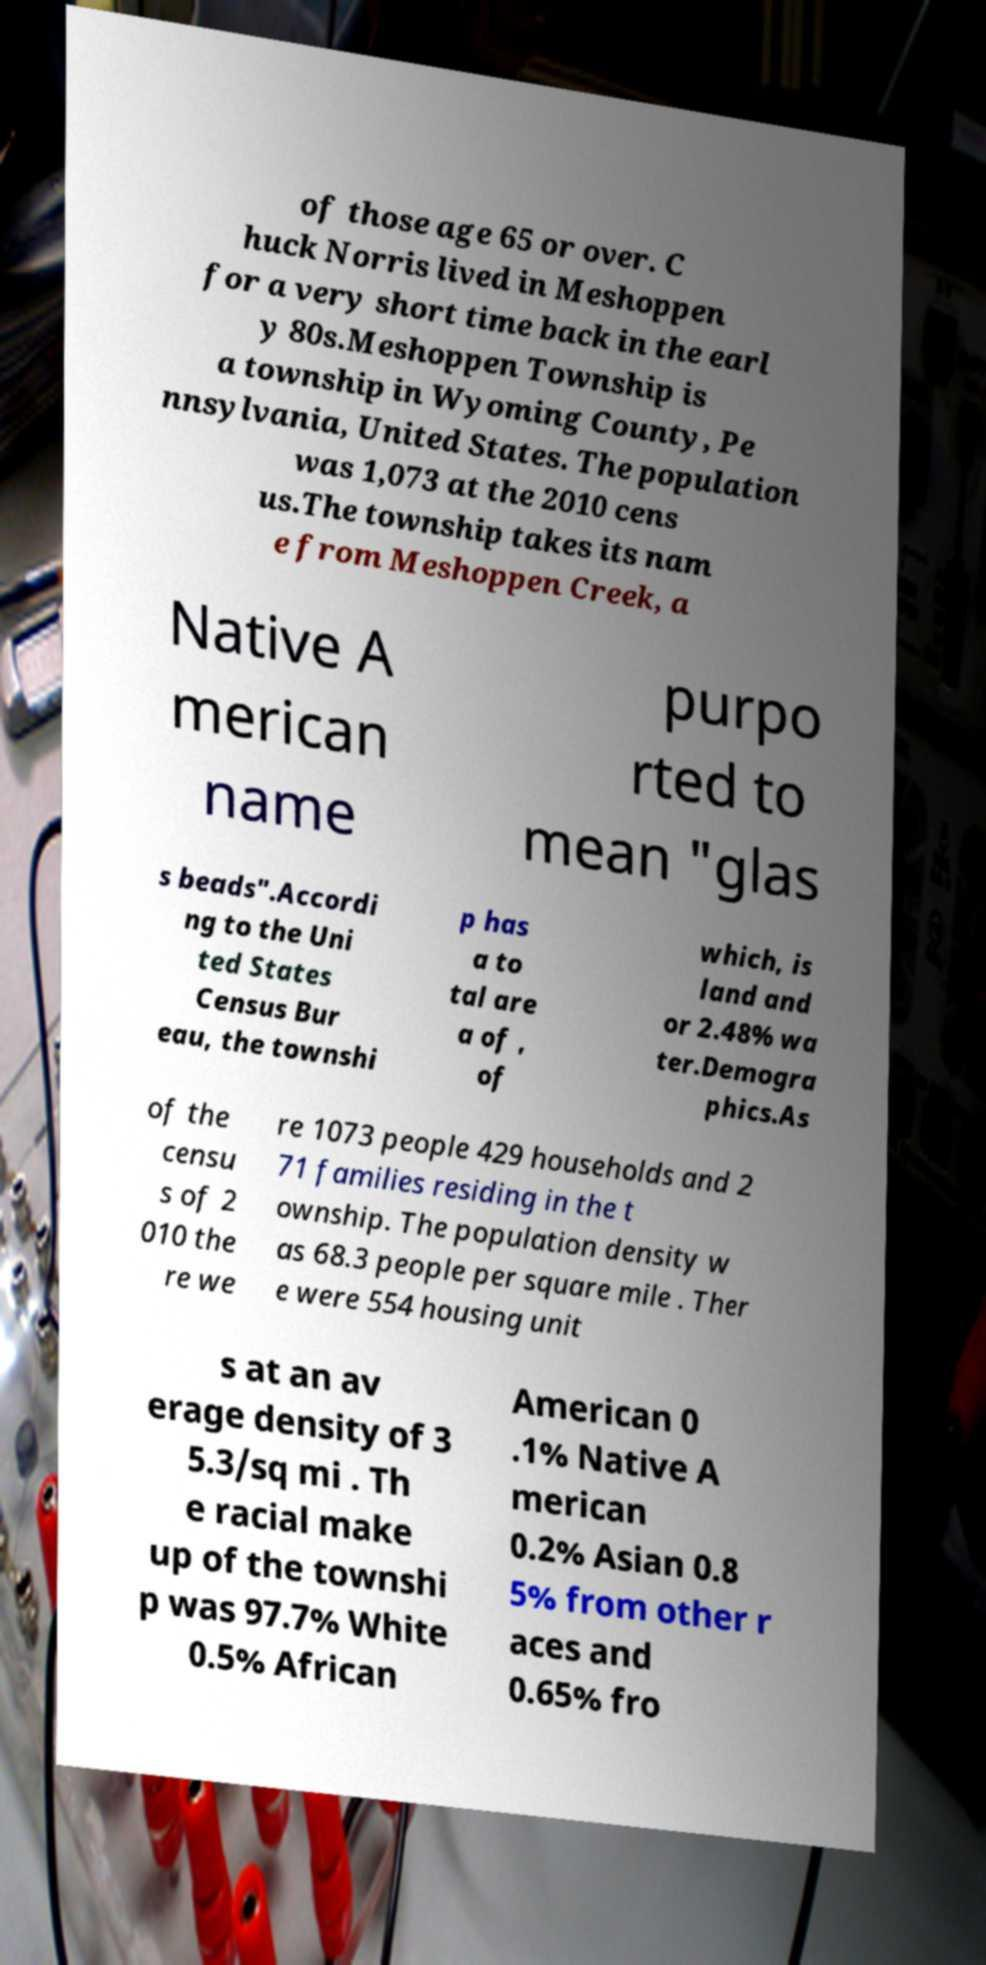Please identify and transcribe the text found in this image. of those age 65 or over. C huck Norris lived in Meshoppen for a very short time back in the earl y 80s.Meshoppen Township is a township in Wyoming County, Pe nnsylvania, United States. The population was 1,073 at the 2010 cens us.The township takes its nam e from Meshoppen Creek, a Native A merican name purpo rted to mean "glas s beads".Accordi ng to the Uni ted States Census Bur eau, the townshi p has a to tal are a of , of which, is land and or 2.48% wa ter.Demogra phics.As of the censu s of 2 010 the re we re 1073 people 429 households and 2 71 families residing in the t ownship. The population density w as 68.3 people per square mile . Ther e were 554 housing unit s at an av erage density of 3 5.3/sq mi . Th e racial make up of the townshi p was 97.7% White 0.5% African American 0 .1% Native A merican 0.2% Asian 0.8 5% from other r aces and 0.65% fro 